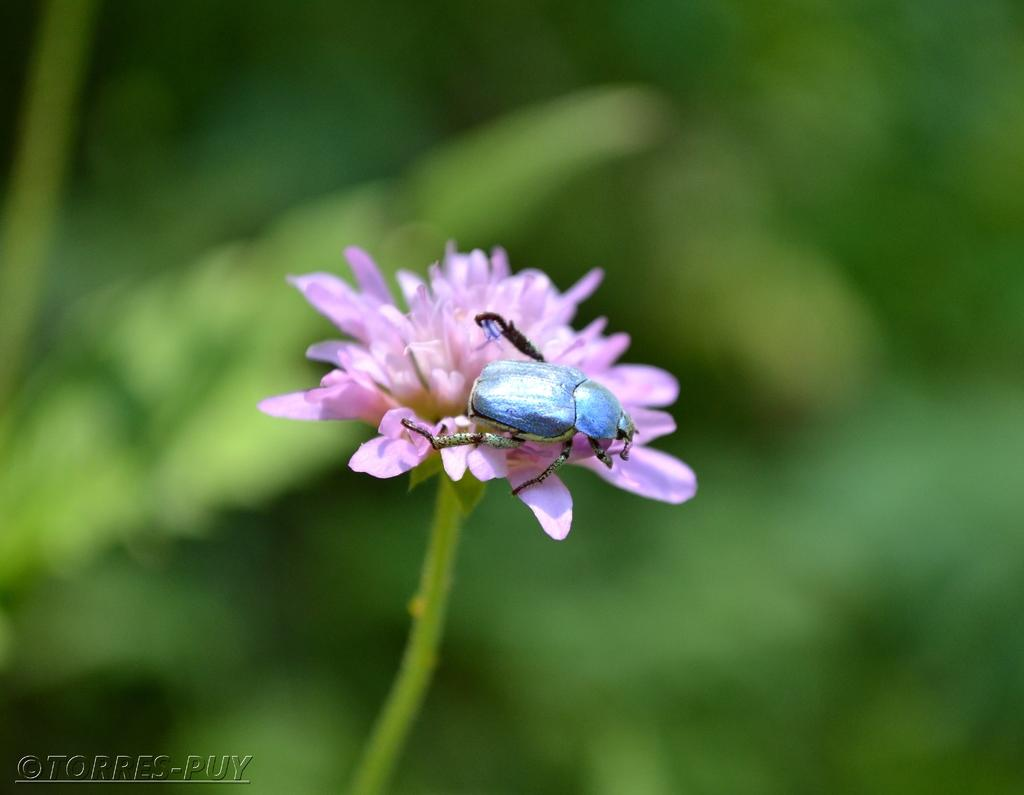What is the main subject of the image? There is a bug on a flower in the image. Can you describe the background of the image? The background of the image is blurred. Is there any additional information or branding present in the image? Yes, there is a watermark in the bottom left corner of the image. How many kittens are sitting on the seat in the image? There are no kittens or seats present in the image; it features a bug on a flower. What type of insect is shown interacting with the flower in the image? The image only shows a bug on a flower, and no specific interaction is depicted. 